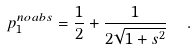<formula> <loc_0><loc_0><loc_500><loc_500>p _ { 1 } ^ { n o a b s } = \frac { 1 } { 2 } + \frac { 1 } { 2 \sqrt { 1 + s ^ { 2 } } } \ \ .</formula> 